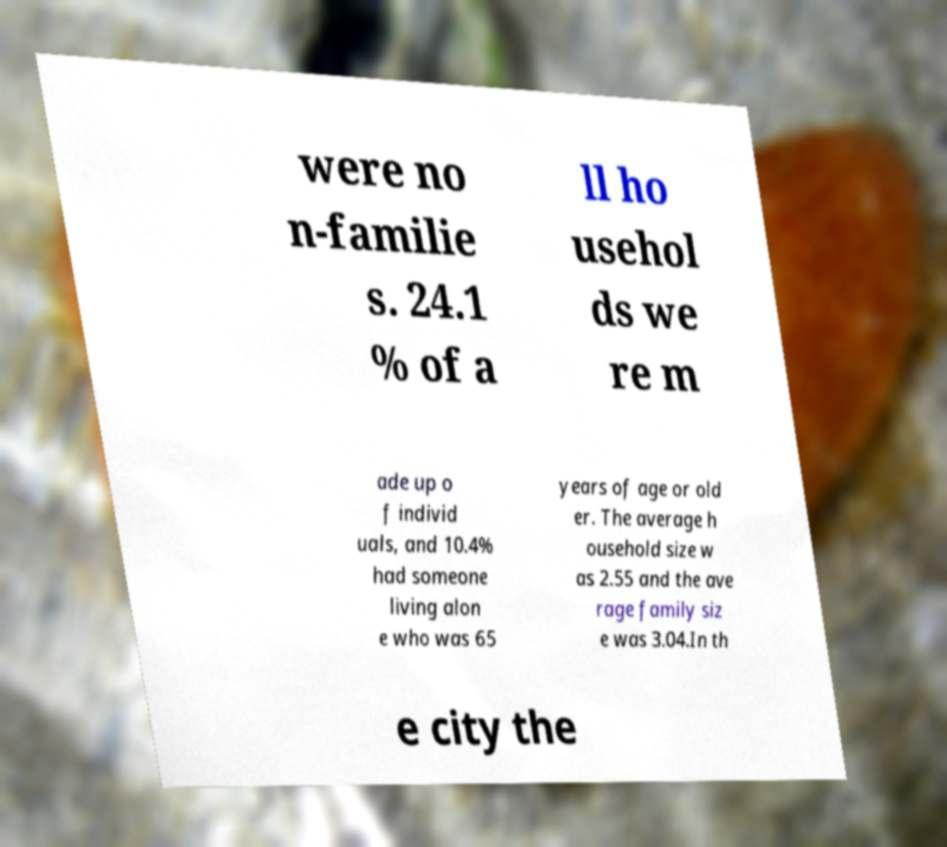I need the written content from this picture converted into text. Can you do that? were no n-familie s. 24.1 % of a ll ho usehol ds we re m ade up o f individ uals, and 10.4% had someone living alon e who was 65 years of age or old er. The average h ousehold size w as 2.55 and the ave rage family siz e was 3.04.In th e city the 